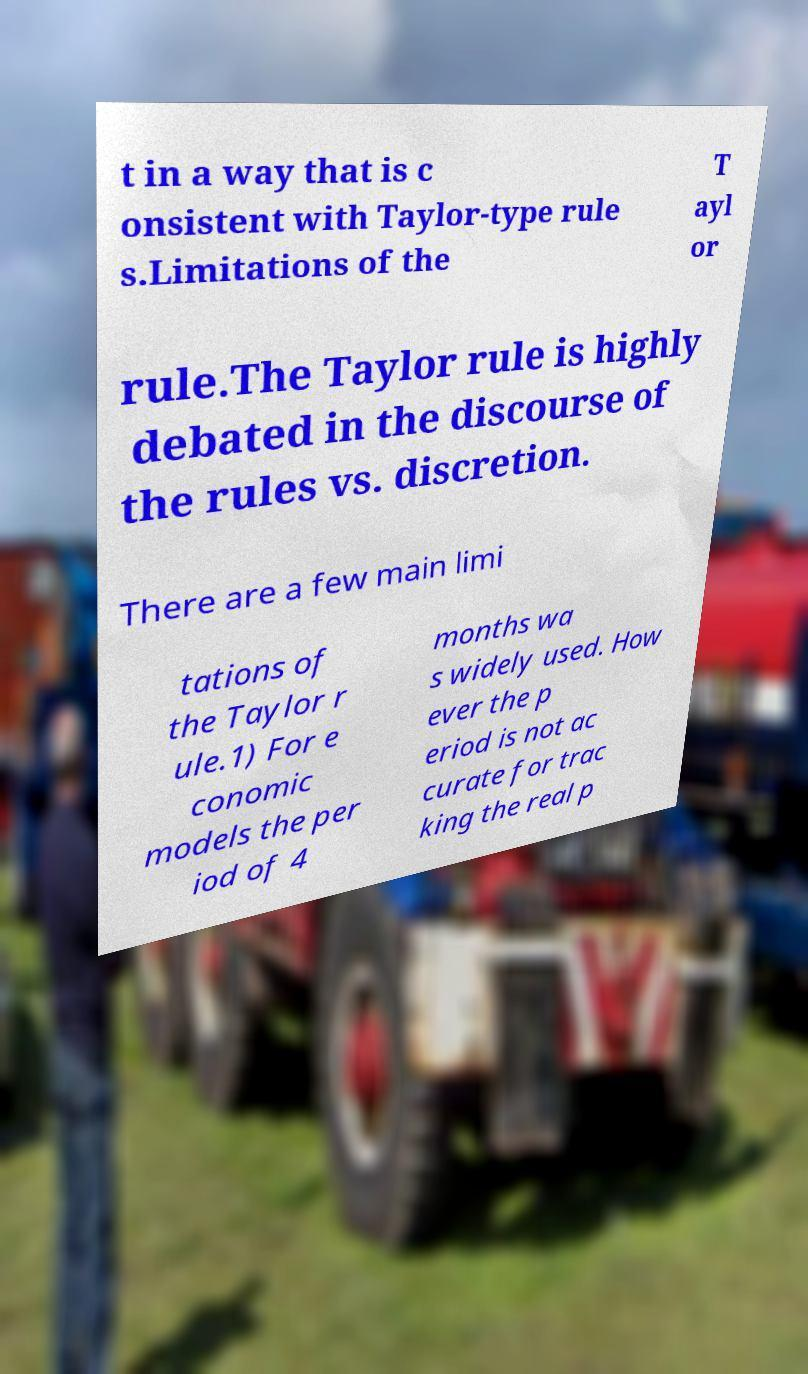Could you extract and type out the text from this image? t in a way that is c onsistent with Taylor-type rule s.Limitations of the T ayl or rule.The Taylor rule is highly debated in the discourse of the rules vs. discretion. There are a few main limi tations of the Taylor r ule.1) For e conomic models the per iod of 4 months wa s widely used. How ever the p eriod is not ac curate for trac king the real p 